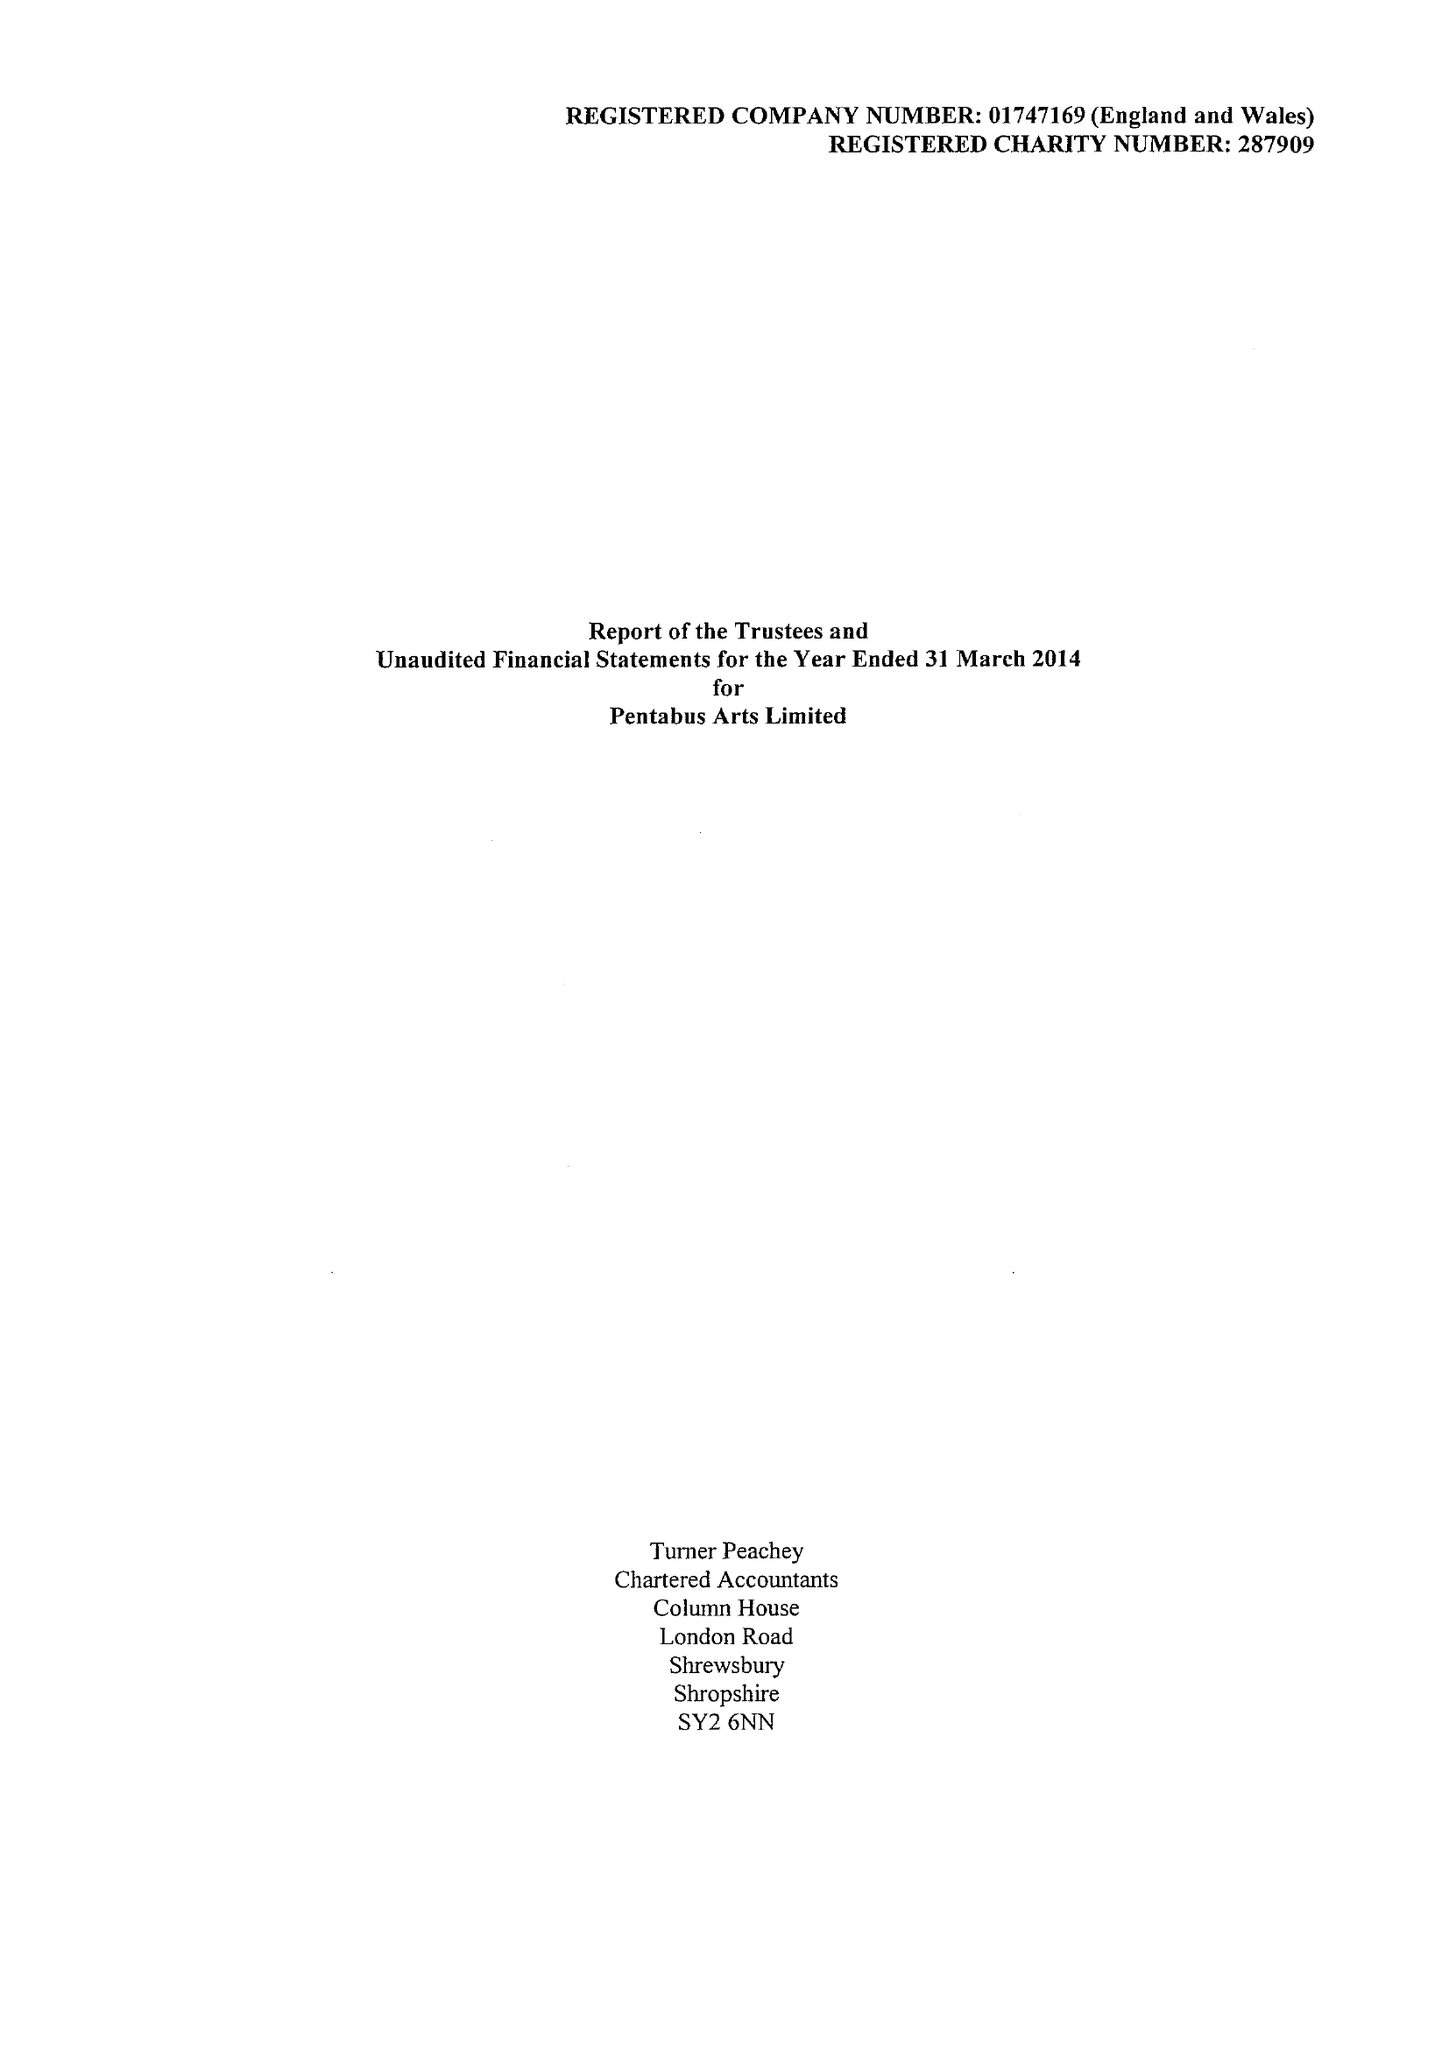What is the value for the charity_name?
Answer the question using a single word or phrase. Pentabus Arts Ltd. 